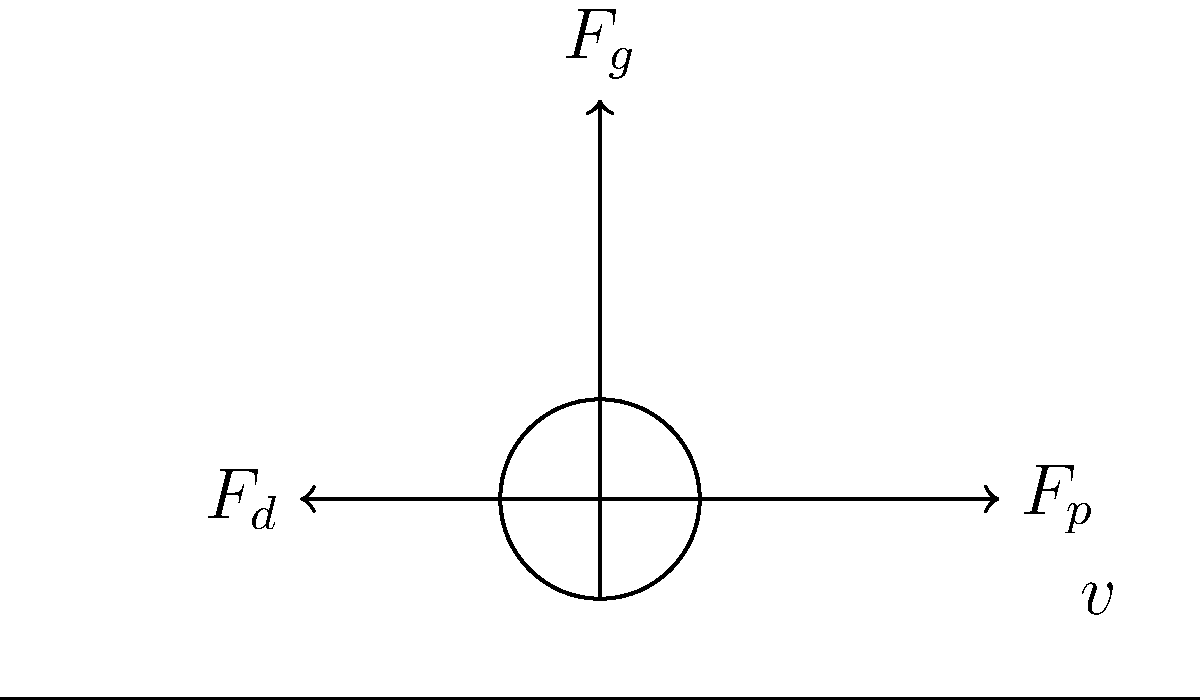As Martin van Steen's former coach, you're analyzing his cycling performance. The aerodynamic drag force $F_d$ on a cyclist is given by the equation $F_d = \frac{1}{2}\rho C_d A v^2$, where $\rho$ is the air density, $C_d$ is the drag coefficient, $A$ is the frontal area, and $v$ is the velocity. If the drag force on Martin at 10 m/s is 40 N, what would be the drag force when he increases his speed to 15 m/s, assuming all other factors remain constant? Let's approach this step-by-step:

1) We're given that $F_d = \frac{1}{2}\rho C_d A v^2$

2) At 10 m/s, $F_d = 40$ N. Let's call the constant term $k = \frac{1}{2}\rho C_d A$

3) So, $40 = k(10)^2 = 100k$

4) Therefore, $k = \frac{40}{100} = 0.4$

5) Now, for 15 m/s, we can use this $k$ value:

   $F_d = 0.4(15)^2 = 0.4(225) = 90$ N

6) We can verify this using the relationship between force and velocity:

   $\frac{F_2}{F_1} = (\frac{v_2}{v_1})^2$

   $\frac{F_2}{40} = (\frac{15}{10})^2 = (\frac{3}{2})^2 = \frac{9}{4} = 2.25$

   $F_2 = 40 * 2.25 = 90$ N

Thus, the drag force at 15 m/s would be 90 N.
Answer: 90 N 